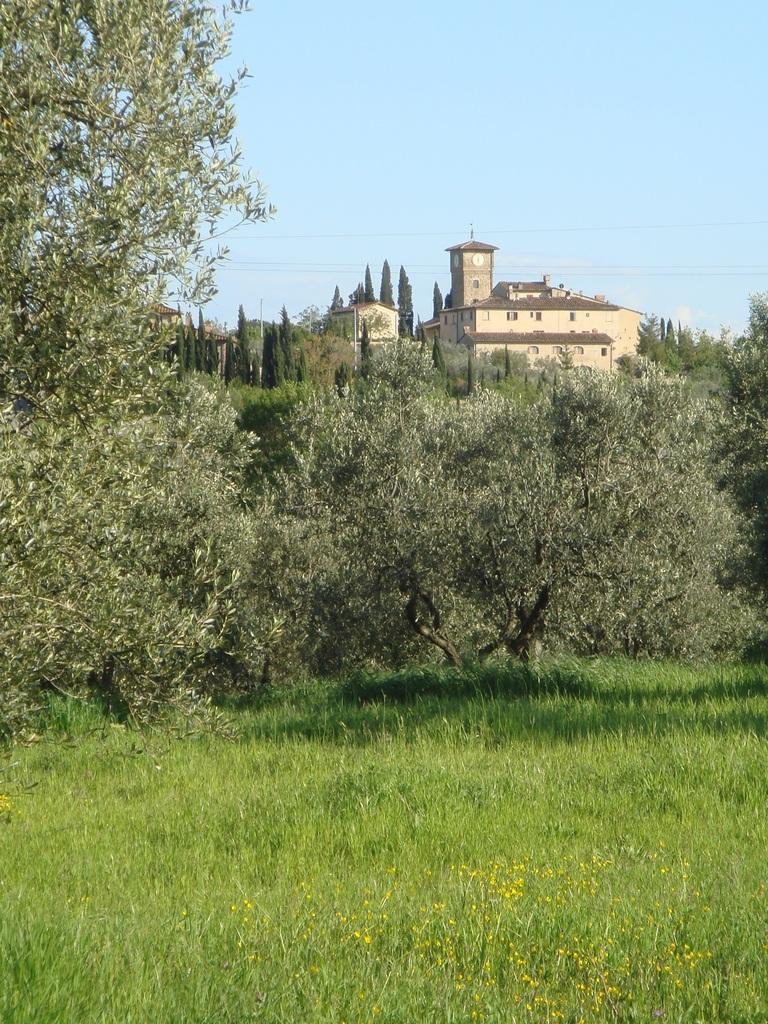Can you describe this image briefly? In the center of the image we can see the sky, buildings, trees, grass, flowers and a few other objects. 